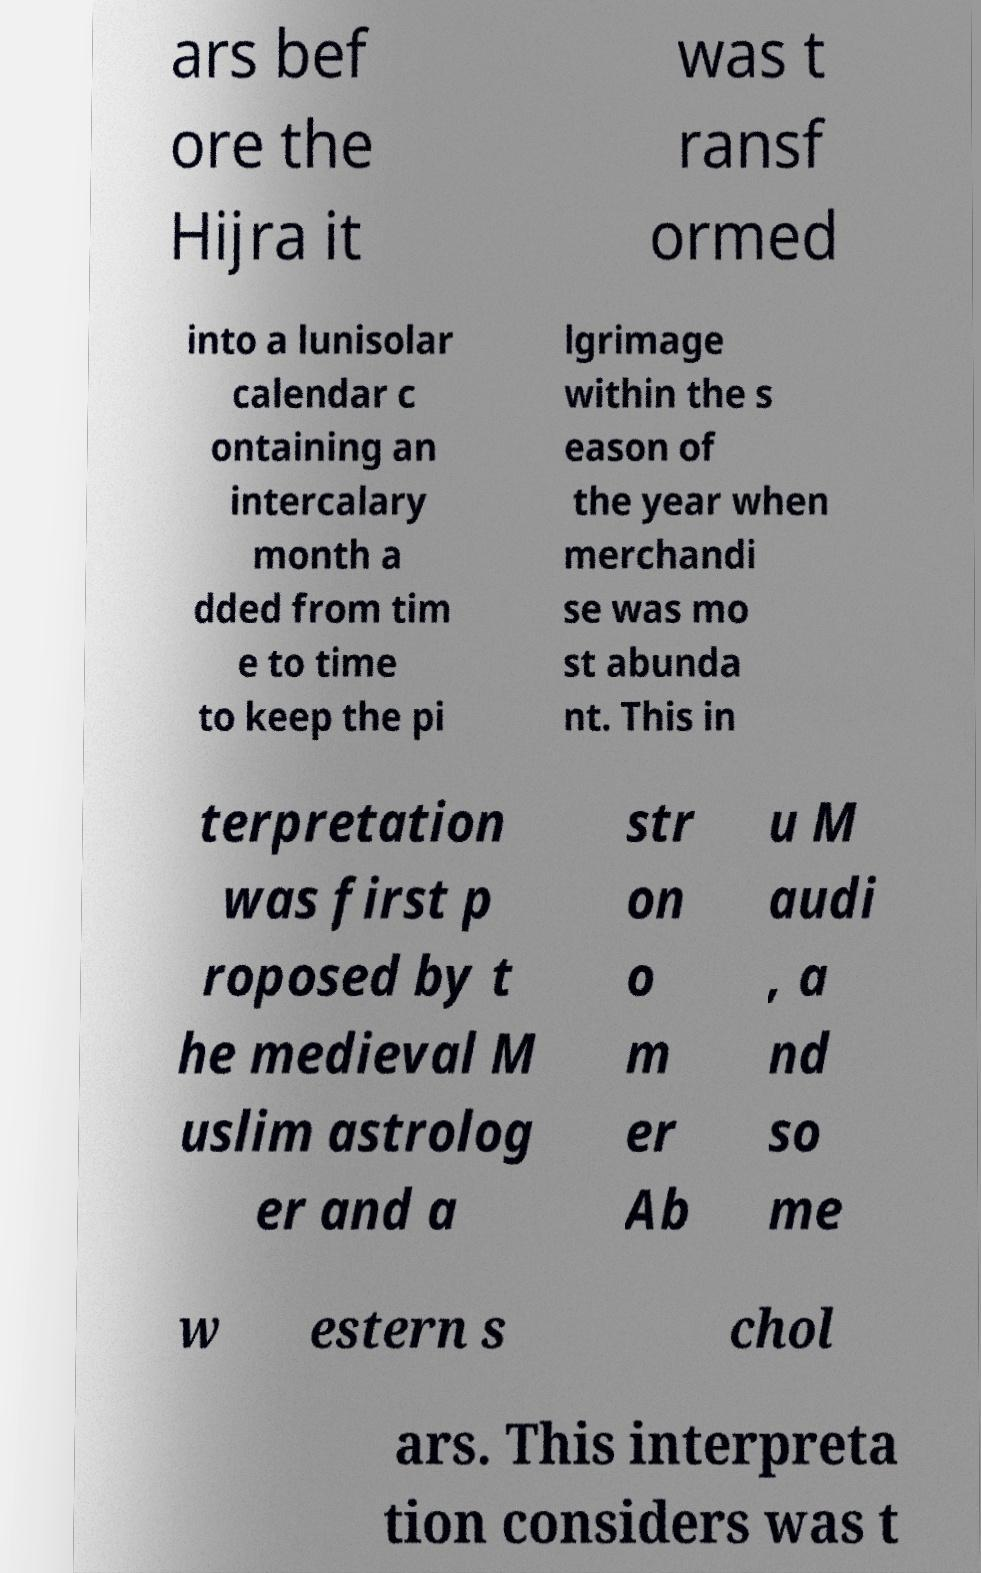What messages or text are displayed in this image? I need them in a readable, typed format. ars bef ore the Hijra it was t ransf ormed into a lunisolar calendar c ontaining an intercalary month a dded from tim e to time to keep the pi lgrimage within the s eason of the year when merchandi se was mo st abunda nt. This in terpretation was first p roposed by t he medieval M uslim astrolog er and a str on o m er Ab u M audi , a nd so me w estern s chol ars. This interpreta tion considers was t 